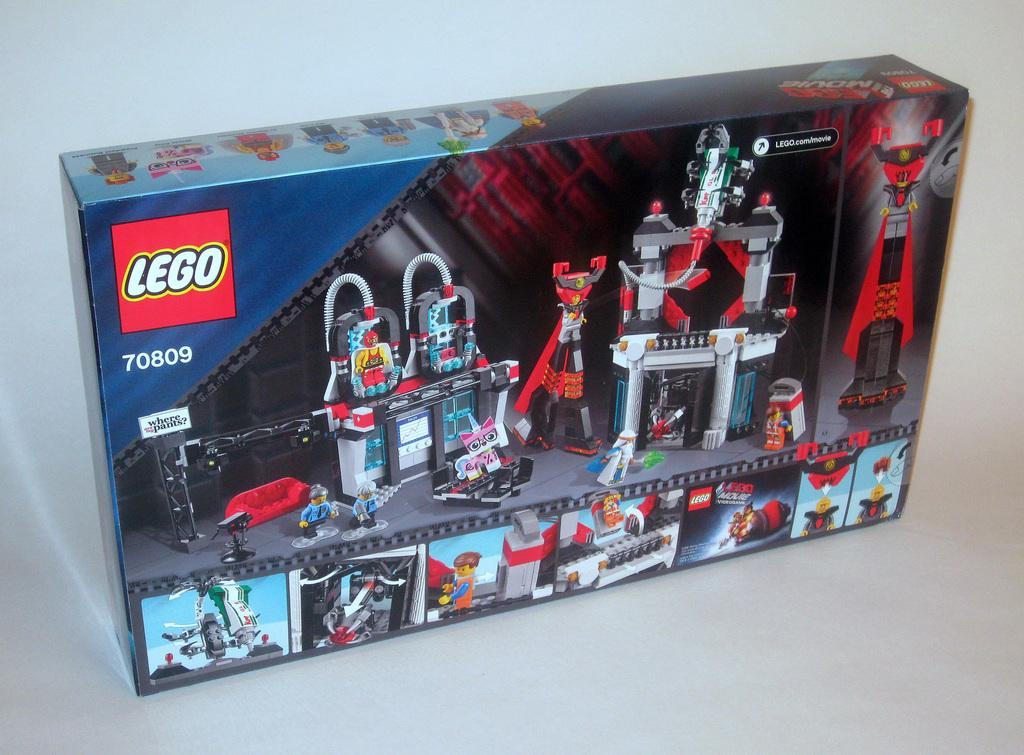What object is present in the image that might be used for storing toys? There is a toy box in the image. What type of toys can be found inside the toy box? The toy box contains Lego toys. Are there any visual representations of the toys on the toy box? Yes, there are images of the toys on the box. Where is the text located on the toy box? The text is in the left side top corner of the box. Reasoning: Let's think step by step by step in order to produce the conversation. We start by identifying the main object in the image, which is the toy box. Then, we describe the contents of the toy box, focusing on the specific type of toys it contains. Next, we mention the presence of images on the toy box, which provide additional information about the toys. Finally, we identify the location of the text on the toy box, which might provide further details about the product or its contents. Absurd Question/Answer: How many marbles are visible inside the toy box? There are no marbles visible inside the toy box; it contains Lego toys. Can you describe the play area where the children are using the basket to store their toys? There is no play area or basket mentioned in the image or the provided facts. 